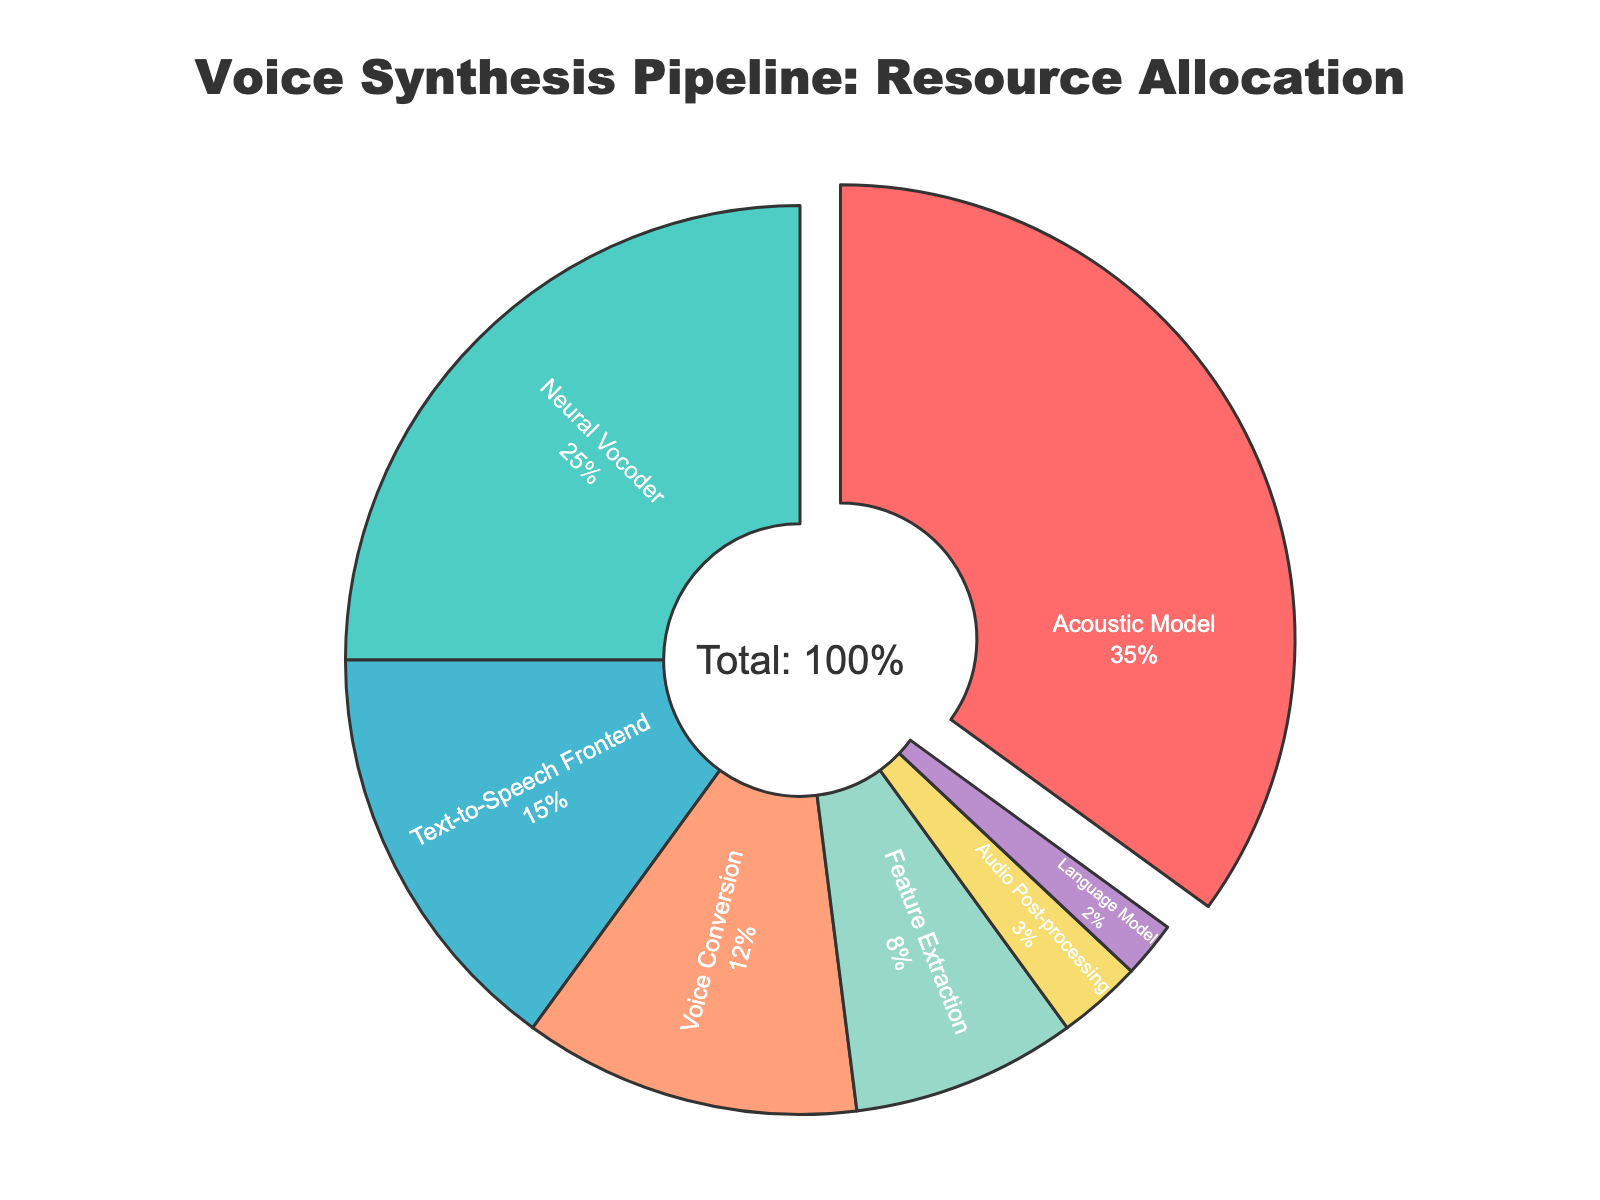Which component has the highest allocation of computing resources? The component with the highest percentage value in the pie chart represents the highest allocation of resources. In this case, the Acoustic Model has 35%, which is the highest among all components.
Answer: Acoustic Model Which two components together make up 40% of the total resources? Identify the components with the given percentages and sum them to find pairs that total 40%. Here, Text-to-Speech Frontend (15%) and Voice Conversion (12%) combined with Feature Extraction (8%) equal exactly 40%.
Answer: Text-to-Speech Frontend and Voice Conversion and Feature Extraction How much more resources are allocated to the Neural Vocoder compared to the Language Model? Find the percentages for Neural Vocoder (25%) and Language Model (2%), and calculate the difference: 25% - 2% = 23%.
Answer: 23% Are the resources allocated to Audio Post-processing greater than those for Feature Extraction? Compare the percentages of Audio Post-processing (3%) and Feature Extraction (8%). 3% is less than 8%.
Answer: No What's the combined allocation for Voice Conversion, Feature Extraction, and Audio Post-processing? Sum the percentages of Voice Conversion (12%), Feature Extraction (8%), and Audio Post-processing (3%): 12% + 8% + 3% = 23%.
Answer: 23% Which component has the second highest allocation of resources? From the pie chart, the second highest percentage is for the Neural Vocoder, which has 25%.
Answer: Neural Vocoder What is the resource difference between Text-to-Speech Frontend and Acoustic Model? Calculate the difference between Text-to-Speech Frontend (15%) and Acoustic Model (35%): 35% - 15% = 20%.
Answer: 20% Is the allocation for the Acoustic Model more than double that of the Text-to-Speech Frontend? Double the percentage of Text-to-Speech Frontend (15%) is 30%. Check if the Acoustic Model's percentage (35%) is greater than 30%.
Answer: Yes Which components combined form more than 50% of the resource allocation? Starting with the highest values, combine them until they exceed 50%. Acoustic Model (35%) + Neural Vocoder (25%) = 60%, which exceeds 50%.
Answer: Acoustic Model and Neural Vocoder What is the percentage allocation for components marked with colors red and pink? Identify the colors from the legend; in this case, the Acoustic Model (35%, red) and Neural Vocoder (25%, pink) together sum up their percentages: 35% + 25% = 60%.
Answer: 60% 